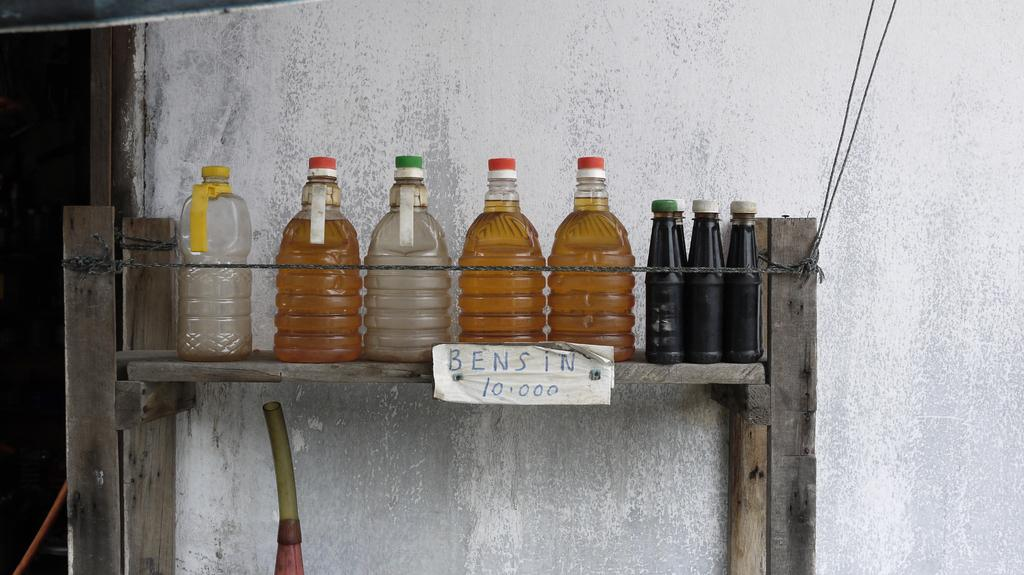What objects are present in the image? There are various types of bottles in the image. What is inside the bottles? The bottles contain liquid. How are the bottles arranged in the image? The bottles are placed on a wooden rack. What is located below the wooden rack? There is a pipe below the wooden rack. Is there any text or writing visible in the image? Yes, there is a paper with writing on it in the image. What type of mine can be seen in the background of the image? There is no mine present in the image; it only features bottles, a wooden rack, a pipe, and a paper with writing on it. 